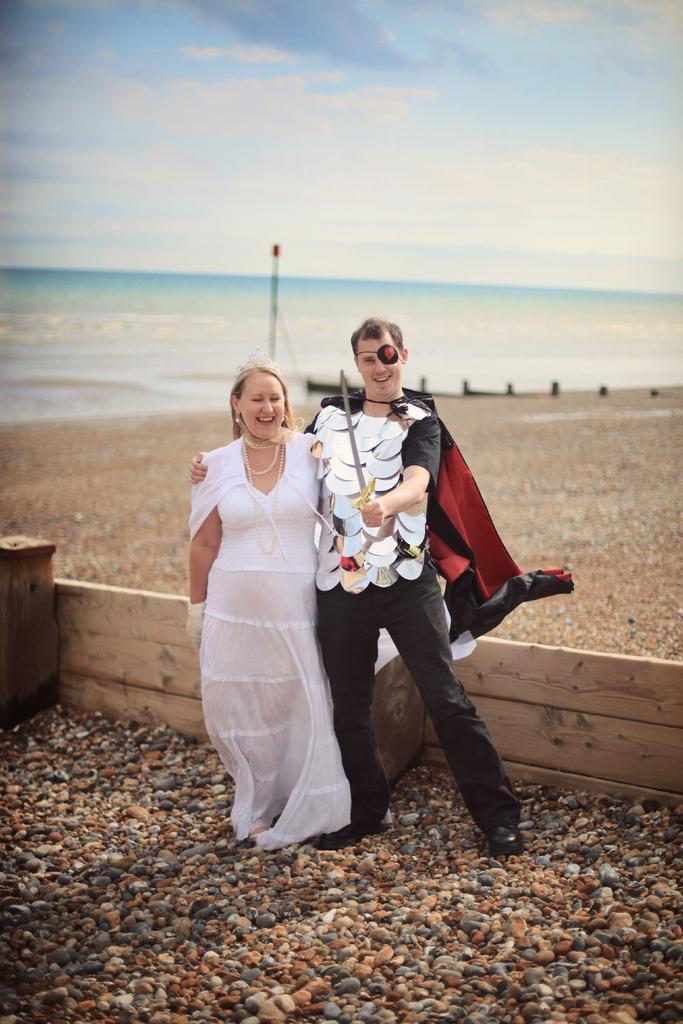Please provide a concise description of this image. In this image I can see a man and a woman. I can see he is wearing a costume and he is holding a sword. On the left side I can see she is wearing a gown and I can also see smile on their faces. In the background I can see a pole, water, clouds and the sky. I can also see number of stones and the wooden wall on the ground. I can see this image is little bit blurry in the background. 